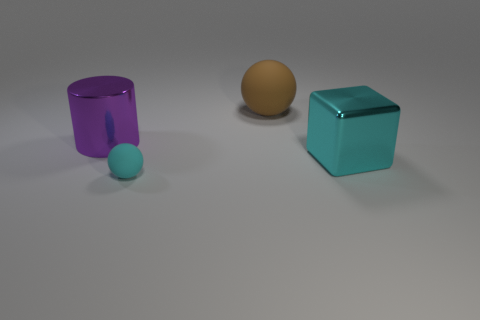Is the number of brown spheres on the right side of the large cyan metallic block less than the number of large matte balls?
Your response must be concise. Yes. What number of shiny things are small cyan objects or large yellow blocks?
Your answer should be compact. 0. Is the metal cylinder the same color as the big rubber thing?
Offer a very short reply. No. Is there anything else of the same color as the tiny sphere?
Your response must be concise. Yes. There is a tiny cyan object in front of the brown ball; is it the same shape as the rubber object that is to the right of the small cyan thing?
Provide a short and direct response. Yes. How many things are purple cylinders or things to the left of the cyan shiny thing?
Provide a short and direct response. 3. What number of other things are the same size as the purple metallic cylinder?
Make the answer very short. 2. Do the cyan object that is on the right side of the big brown ball and the thing that is behind the big purple shiny object have the same material?
Your response must be concise. No. There is a big cylinder; how many metallic things are in front of it?
Give a very brief answer. 1. How many cyan objects are either small metallic cubes or large shiny cubes?
Keep it short and to the point. 1. 